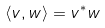Convert formula to latex. <formula><loc_0><loc_0><loc_500><loc_500>\langle v , w \rangle = v ^ { * } w</formula> 